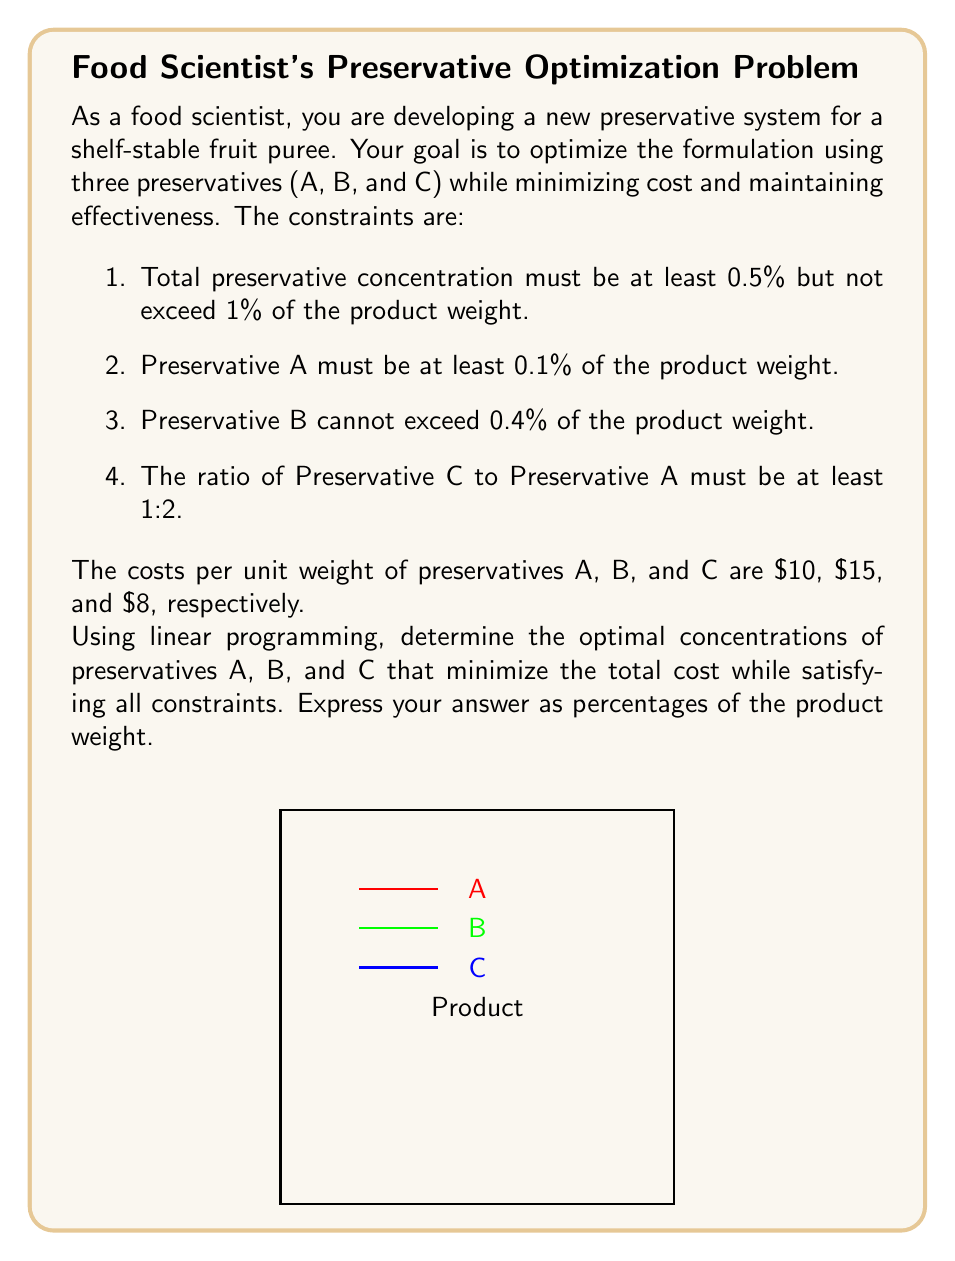Could you help me with this problem? Let's solve this problem step by step using linear programming:

1) Define variables:
   Let $x_A$, $x_B$, and $x_C$ be the percentages of preservatives A, B, and C respectively.

2) Objective function:
   Minimize $Z = 10x_A + 15x_B + 8x_C$

3) Constraints:
   a) Total concentration: $0.5 \leq x_A + x_B + x_C \leq 1$
   b) Minimum A: $x_A \geq 0.1$
   c) Maximum B: $x_B \leq 0.4$
   d) Ratio C to A: $x_C \geq 0.5x_A$
   e) Non-negativity: $x_A, x_B, x_C \geq 0$

4) Simplify constraints:
   $x_A + x_B + x_C \geq 0.5$
   $x_A + x_B + x_C \leq 1$
   $x_A \geq 0.1$
   $x_B \leq 0.4$
   $x_C - 0.5x_A \geq 0$

5) Solve using the simplex method or a linear programming solver. The optimal solution is:

   $x_A = 0.1$
   $x_B = 0.35$
   $x_C = 0.05$

6) Verify constraints:
   a) $0.1 + 0.35 + 0.05 = 0.5$ (meets minimum total concentration)
   b) $x_A = 0.1$ (meets minimum A)
   c) $x_B = 0.35 < 0.4$ (meets maximum B)
   d) $0.05 = 0.5 * 0.1$ (meets ratio C to A)

7) Calculate total cost:
   $Z = 10(0.1) + 15(0.35) + 8(0.05) = 1 + 5.25 + 0.4 = 6.65$

This solution minimizes cost while satisfying all constraints.
Answer: A: 0.1%, B: 0.35%, C: 0.05% 